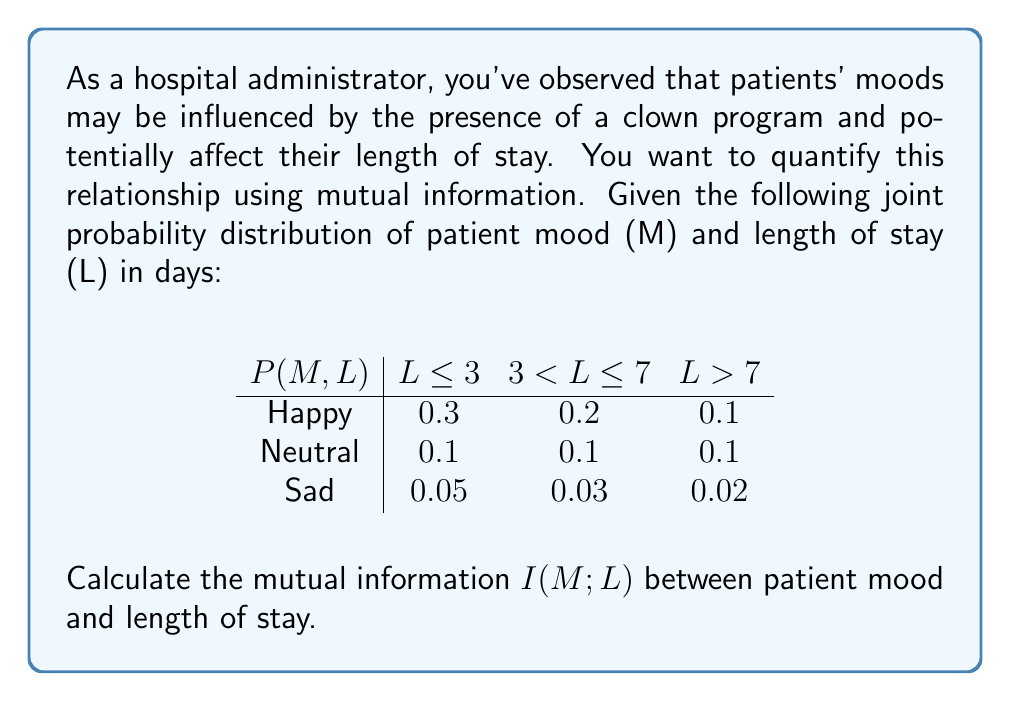Can you answer this question? To calculate the mutual information $I(M;L)$, we'll follow these steps:

1) First, calculate the marginal probabilities $P(M)$ and $P(L)$:

   $P(M = \text{Happy}) = 0.3 + 0.2 + 0.1 = 0.6$
   $P(M = \text{Neutral}) = 0.1 + 0.1 + 0.1 = 0.3$
   $P(M = \text{Sad}) = 0.05 + 0.03 + 0.02 = 0.1$

   $P(L \leq 3) = 0.3 + 0.1 + 0.05 = 0.45$
   $P(3 < L \leq 7) = 0.2 + 0.1 + 0.03 = 0.33$
   $P(L > 7) = 0.1 + 0.1 + 0.02 = 0.22$

2) The mutual information is given by:

   $$I(M;L) = \sum_{m \in M} \sum_{l \in L} P(m,l) \log_2 \frac{P(m,l)}{P(m)P(l)}$$

3) Calculate each term:

   $0.3 \log_2 \frac{0.3}{0.6 \cdot 0.45} \approx 0.1374$
   $0.2 \log_2 \frac{0.2}{0.6 \cdot 0.33} \approx 0.0255$
   $0.1 \log_2 \frac{0.1}{0.6 \cdot 0.22} \approx -0.0944$
   $0.1 \log_2 \frac{0.1}{0.3 \cdot 0.45} \approx 0.0592$
   $0.1 \log_2 \frac{0.1}{0.3 \cdot 0.33} \approx 0.1169$
   $0.1 \log_2 \frac{0.1}{0.3 \cdot 0.22} \approx 0.2075$
   $0.05 \log_2 \frac{0.05}{0.1 \cdot 0.45} \approx 0.0153$
   $0.03 \log_2 \frac{0.03}{0.1 \cdot 0.33} \approx -0.0135$
   $0.02 \log_2 \frac{0.02}{0.1 \cdot 0.22} \approx -0.0134$

4) Sum all these terms:

   $I(M;L) \approx 0.1374 + 0.0255 - 0.0944 + 0.0592 + 0.1169 + 0.2075 + 0.0153 - 0.0135 - 0.0134 \approx 0.4405$

Thus, the mutual information $I(M;L)$ is approximately 0.4405 bits.
Answer: $I(M;L) \approx 0.4405$ bits 